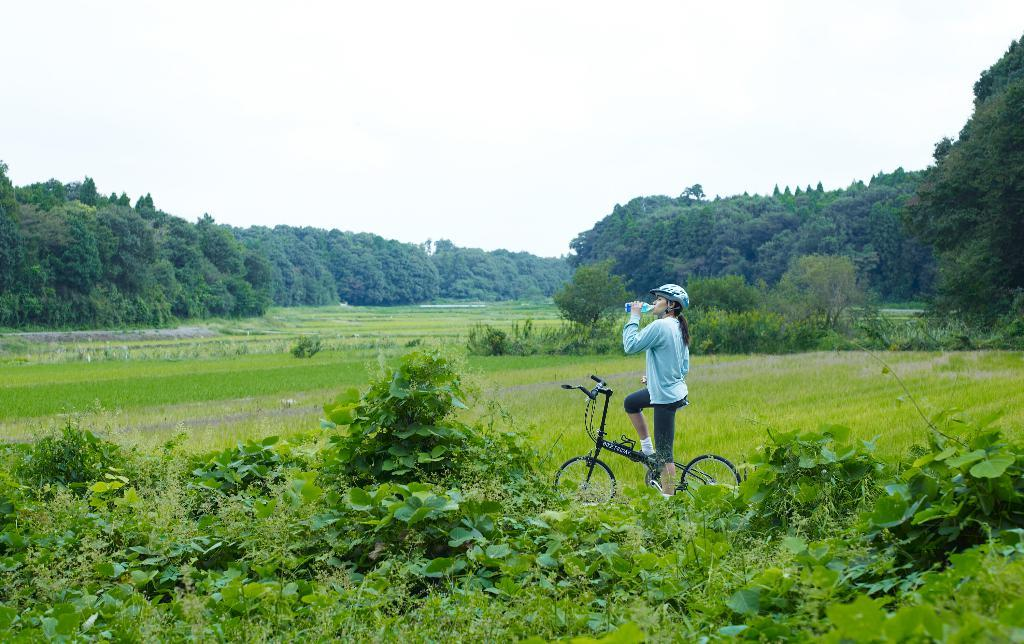Who is present in the image? There is a woman in the image. What is the woman holding? The woman is holding a water bottle. What is the woman sitting on? The woman is sitting on a bicycle. What type of vegetation can be seen in the image? There are plants, grass, and trees in the image. What can be seen in the background of the image? The sky is visible in the background of the image. What type of destruction can be seen in the image? There is no destruction present in the image; it features a woman sitting on a bicycle in a natural setting. How many chickens are visible in the image? There are no chickens present in the image. 